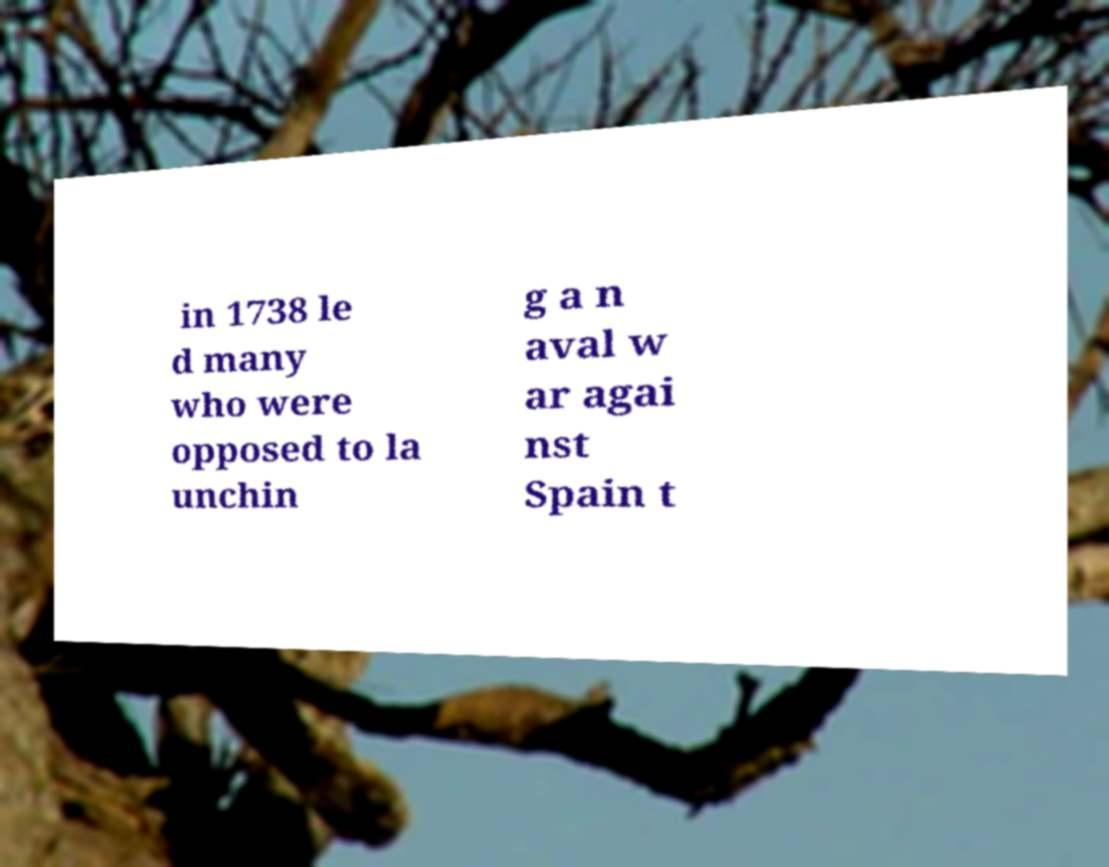Please read and relay the text visible in this image. What does it say? in 1738 le d many who were opposed to la unchin g a n aval w ar agai nst Spain t 